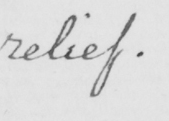Can you read and transcribe this handwriting? relief . 